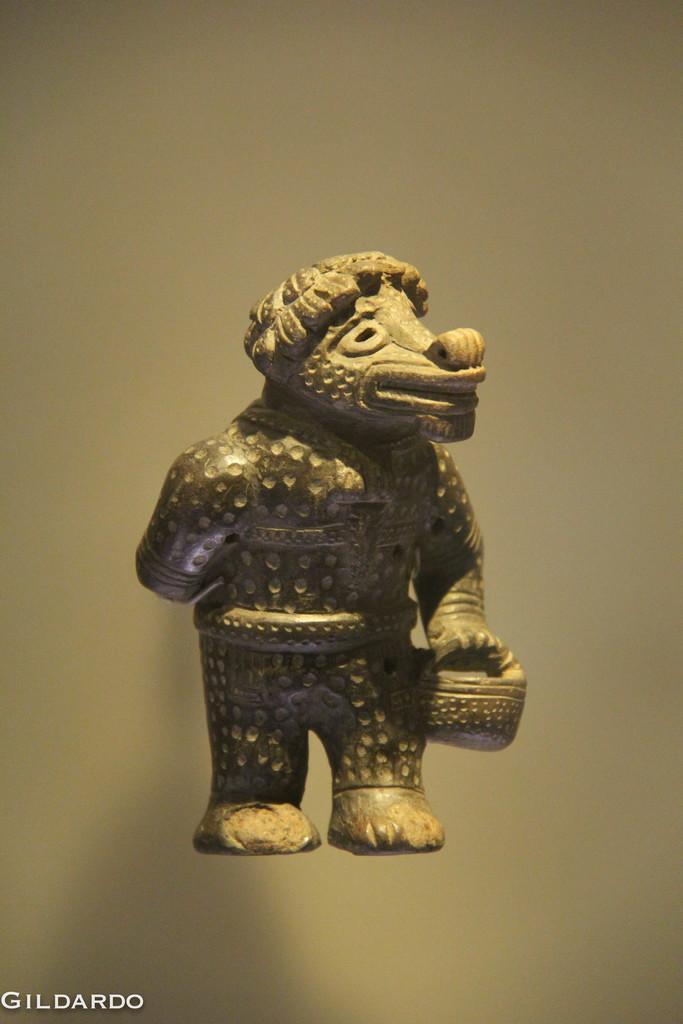Can you describe this image briefly? In this picture we can see a statue and in the background we can see it is blurry, in the bottom left we can see some text on it. 